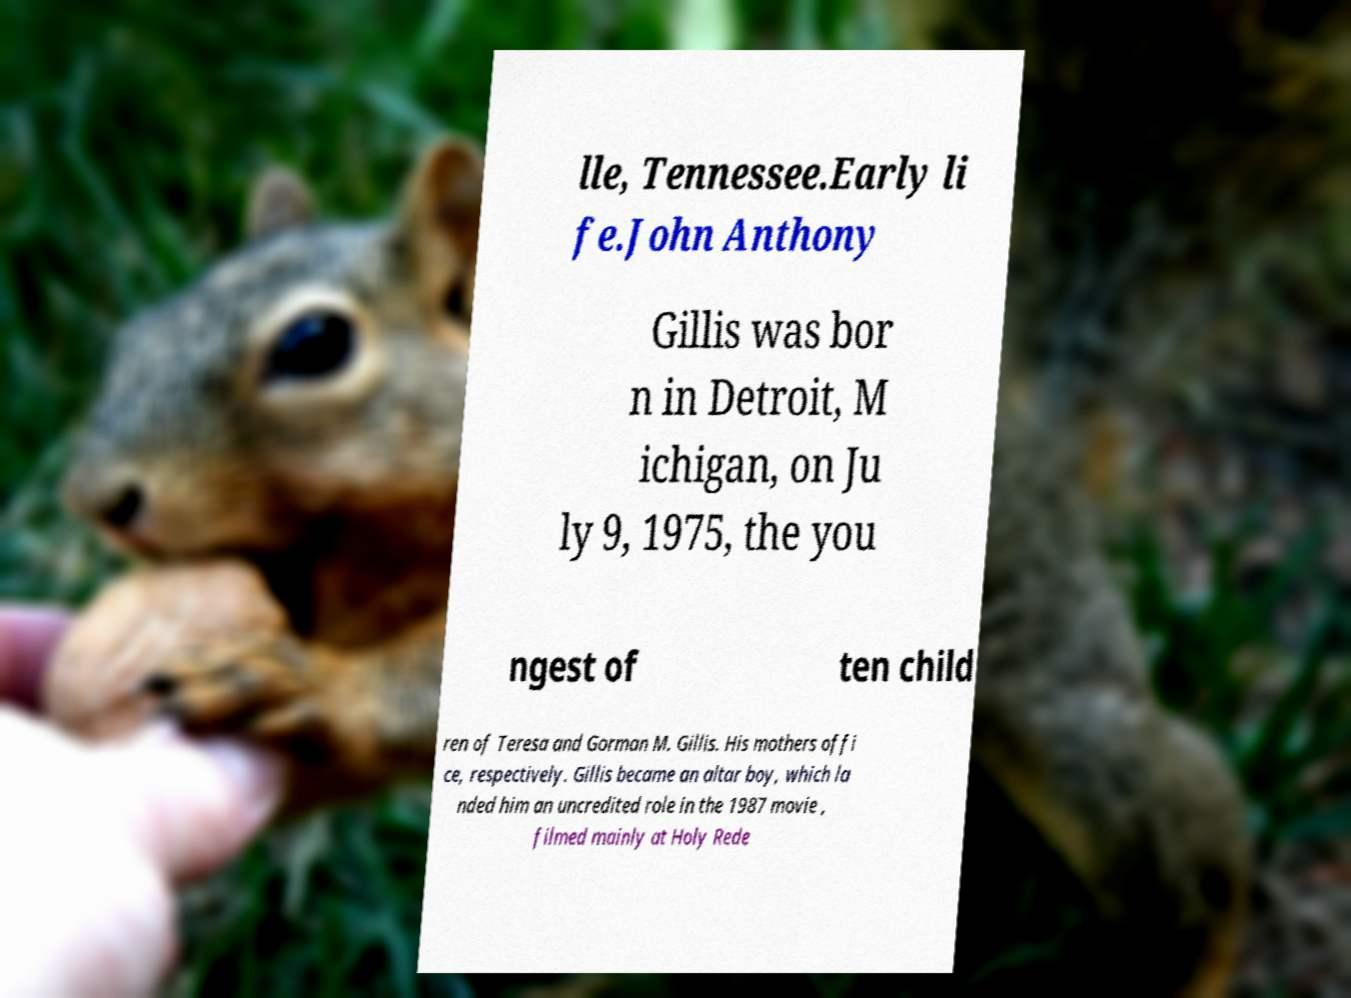What messages or text are displayed in this image? I need them in a readable, typed format. lle, Tennessee.Early li fe.John Anthony Gillis was bor n in Detroit, M ichigan, on Ju ly 9, 1975, the you ngest of ten child ren of Teresa and Gorman M. Gillis. His mothers offi ce, respectively. Gillis became an altar boy, which la nded him an uncredited role in the 1987 movie , filmed mainly at Holy Rede 